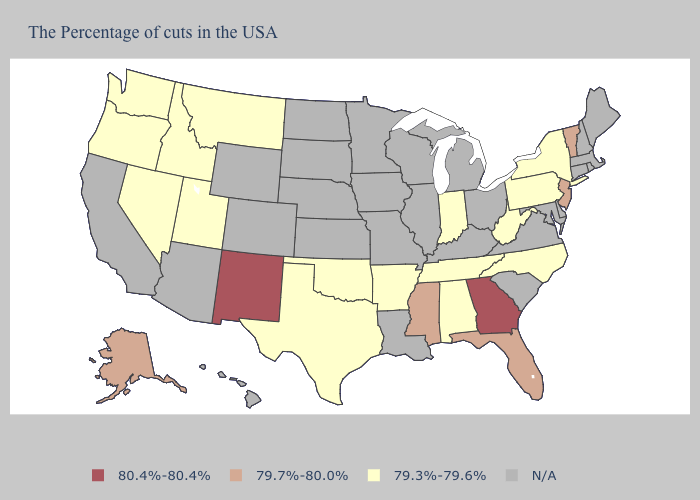Does Washington have the lowest value in the West?
Give a very brief answer. Yes. Which states have the lowest value in the Northeast?
Give a very brief answer. New York, Pennsylvania. What is the value of Virginia?
Give a very brief answer. N/A. Does North Carolina have the highest value in the USA?
Give a very brief answer. No. Does the first symbol in the legend represent the smallest category?
Short answer required. No. What is the lowest value in the USA?
Concise answer only. 79.3%-79.6%. What is the highest value in states that border Idaho?
Quick response, please. 79.3%-79.6%. What is the highest value in states that border West Virginia?
Short answer required. 79.3%-79.6%. Which states have the lowest value in the USA?
Give a very brief answer. New York, Pennsylvania, North Carolina, West Virginia, Indiana, Alabama, Tennessee, Arkansas, Oklahoma, Texas, Utah, Montana, Idaho, Nevada, Washington, Oregon. Name the states that have a value in the range 80.4%-80.4%?
Quick response, please. Georgia, New Mexico. What is the value of Kansas?
Answer briefly. N/A. Name the states that have a value in the range 79.7%-80.0%?
Write a very short answer. Vermont, New Jersey, Florida, Mississippi, Alaska. 